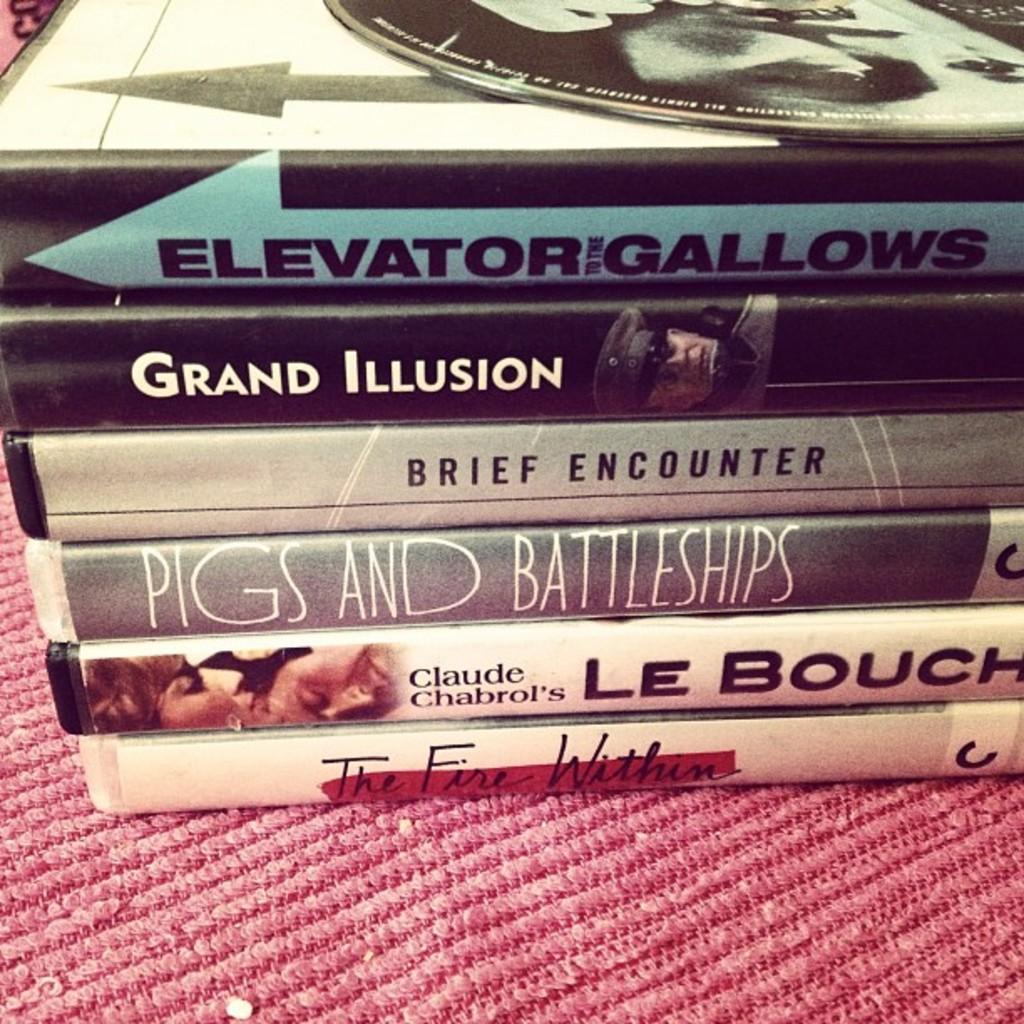Is the book pigs and battleships here?
Your response must be concise. Yes. 